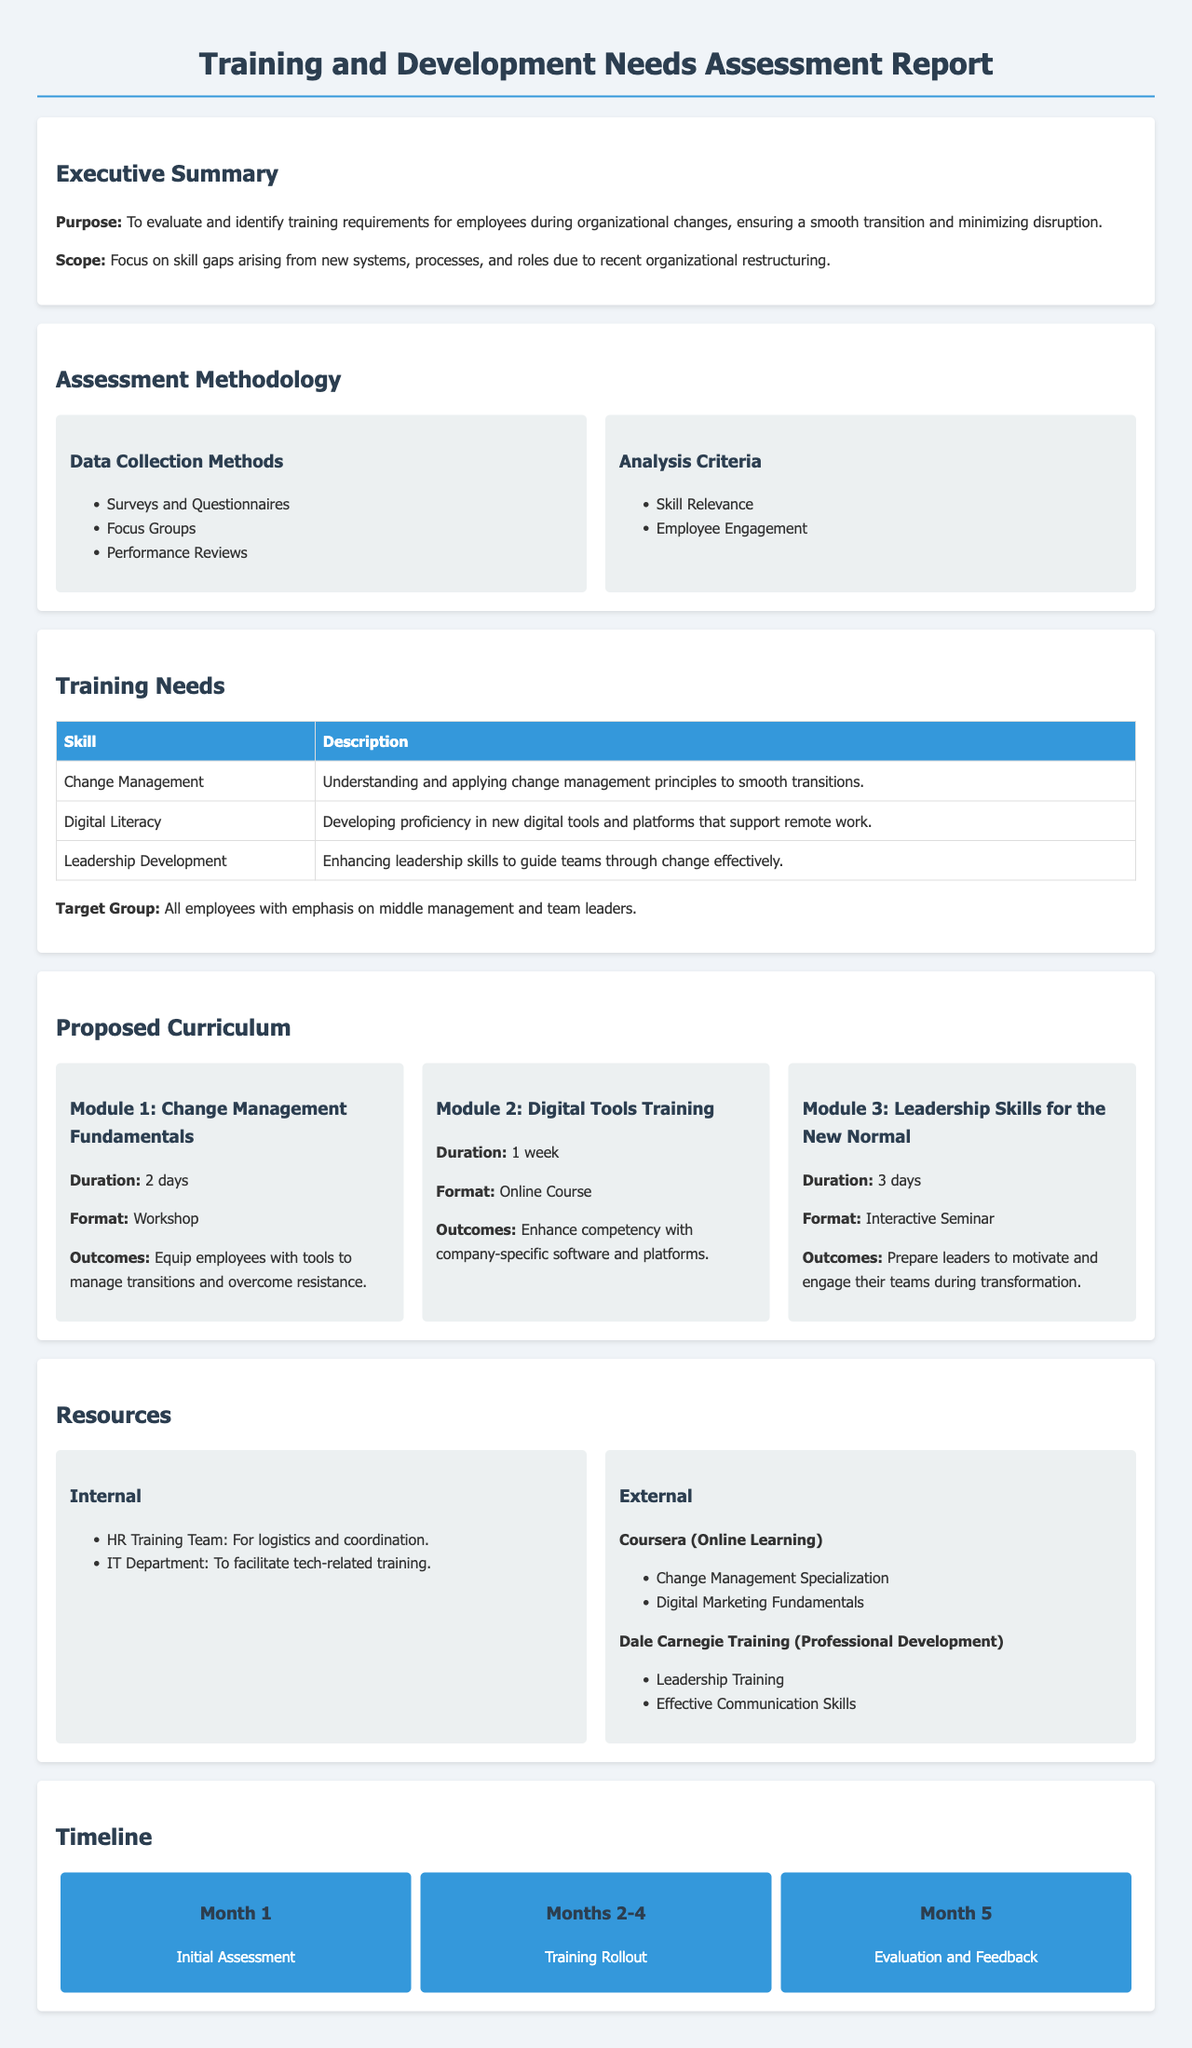What is the purpose of the report? The report aims to evaluate and identify training requirements for employees during organizational changes.
Answer: To evaluate and identify training requirements for employees during organizational changes What is one method used for data collection? The document mentions several data collection methods; one of them is surveys and questionnaires.
Answer: Surveys and Questionnaires Which skill is emphasized for middle management? The report specifies that leadership development is a key skill for middle management.
Answer: Leadership Development How long is the "Change Management Fundamentals" module? The duration of the module is stated within its description in the proposed curriculum.
Answer: 2 days What is the target group for the training needs? The report explicitly states the target group for the training initiatives.
Answer: All employees What is the first step in the timeline? The initial assessment is the first step outlined in the timeline of the training rollout.
Answer: Initial Assessment What is an example of an internal resource mentioned? The document lists the HR Training Team as an internal resource for logistics and coordination.
Answer: HR Training Team During which months will the training rollout occur? The document provides a specific range of months dedicated to the training rollout phase.
Answer: Months 2-4 What is the outcome of the "Digital Tools Training" module? The expected outcome is to enhance competency with company-specific software and platforms as stated in the curriculum.
Answer: Enhance competency with company-specific software and platforms 